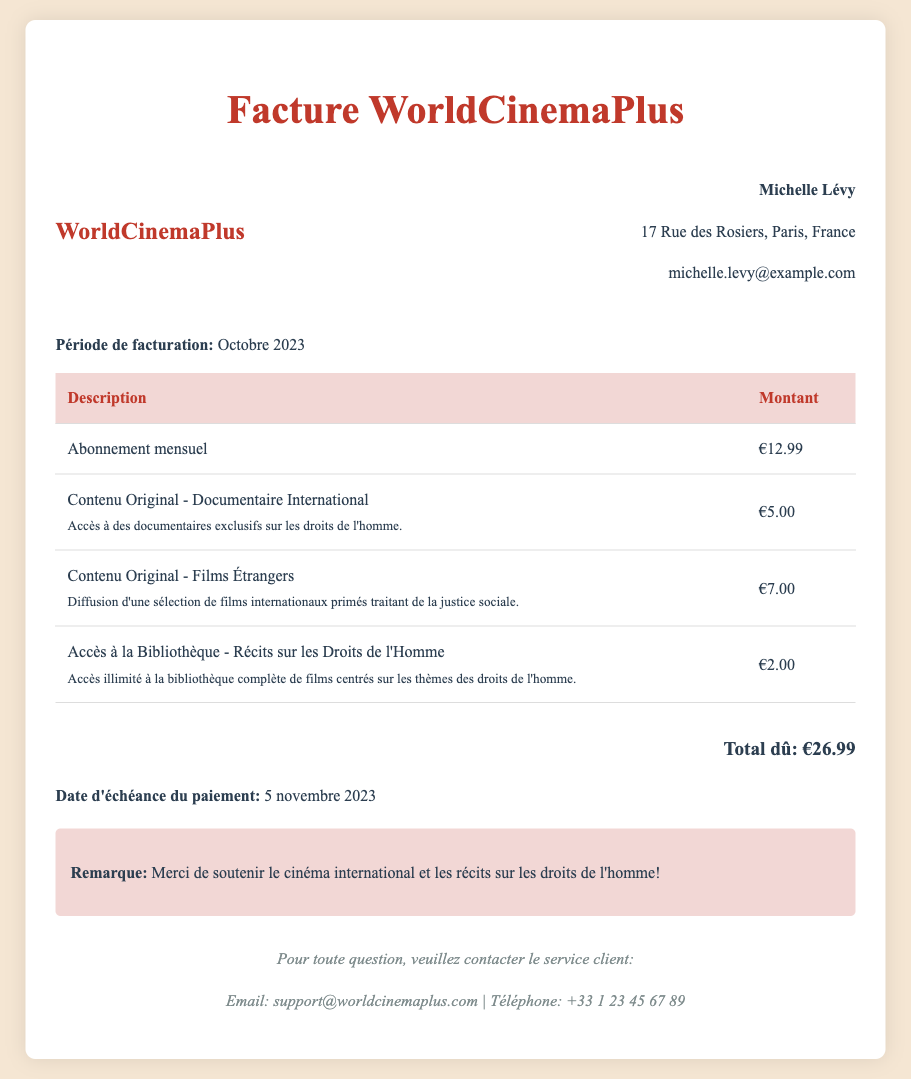What is the name of the streaming service? The name of the streaming service is mentioned in the header of the document as "WorldCinemaPlus."
Answer: WorldCinemaPlus Who is the customer? The customer's name is included at the top of the document, right before their address and email.
Answer: Michelle Lévy What is the total amount due? The total amount due is stated near the bottom of the document, summarizing all charges.
Answer: €26.99 What is the due date for the payment? The due date for payment is specified in the document as the date when payment is expected.
Answer: 5 novembre 2023 How much does the monthly subscription cost? The cost of the monthly subscription is indicated as a separate charge in the table in the document.
Answer: €12.99 What type of content is included in the Original Content charge? The Original Content charge includes a specific type of media, detailed in the document with subcategories.
Answer: Documentaire International, Films Étrangers How much is charged for access to the library of human rights narratives? The total for access to the library is provided in the list of charges for services rendered.
Answer: €2.00 What is the email for customer support? The email for customer support is provided in the footer section of the document.
Answer: support@worldcinemaplus.com What is the additional charge for international documentary content? The document lists the charges for different types of original content, specifying the amount for this particular category.
Answer: €5.00 